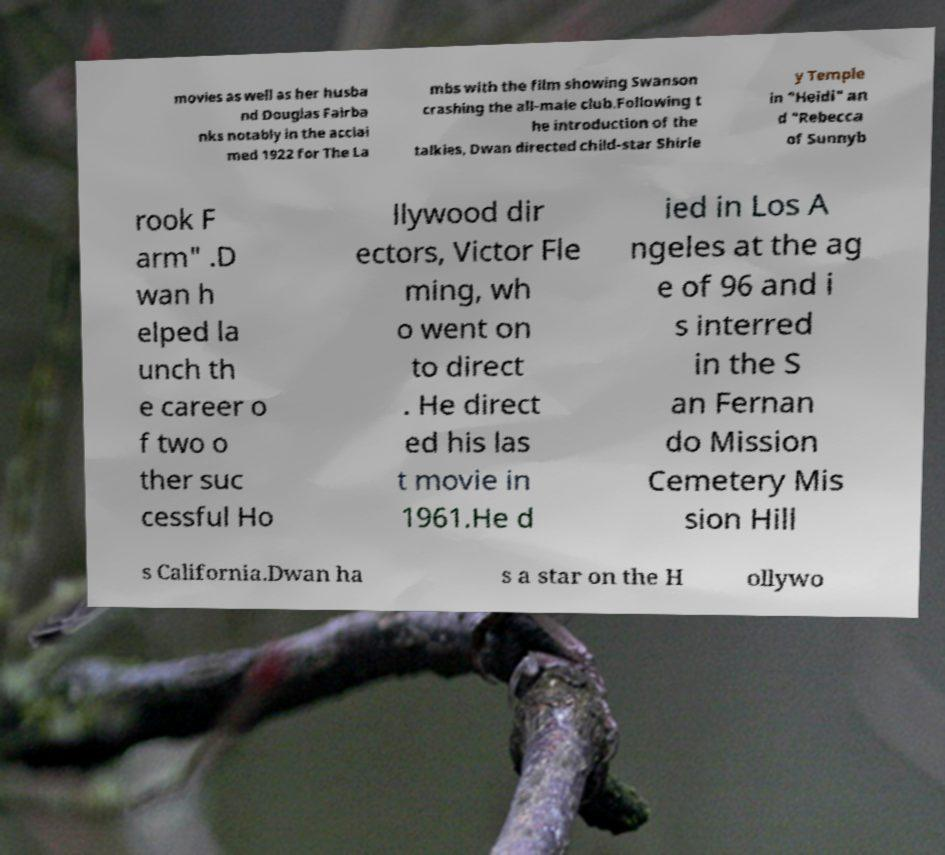Please read and relay the text visible in this image. What does it say? movies as well as her husba nd Douglas Fairba nks notably in the acclai med 1922 for The La mbs with the film showing Swanson crashing the all-male club.Following t he introduction of the talkies, Dwan directed child-star Shirle y Temple in "Heidi" an d "Rebecca of Sunnyb rook F arm" .D wan h elped la unch th e career o f two o ther suc cessful Ho llywood dir ectors, Victor Fle ming, wh o went on to direct . He direct ed his las t movie in 1961.He d ied in Los A ngeles at the ag e of 96 and i s interred in the S an Fernan do Mission Cemetery Mis sion Hill s California.Dwan ha s a star on the H ollywo 